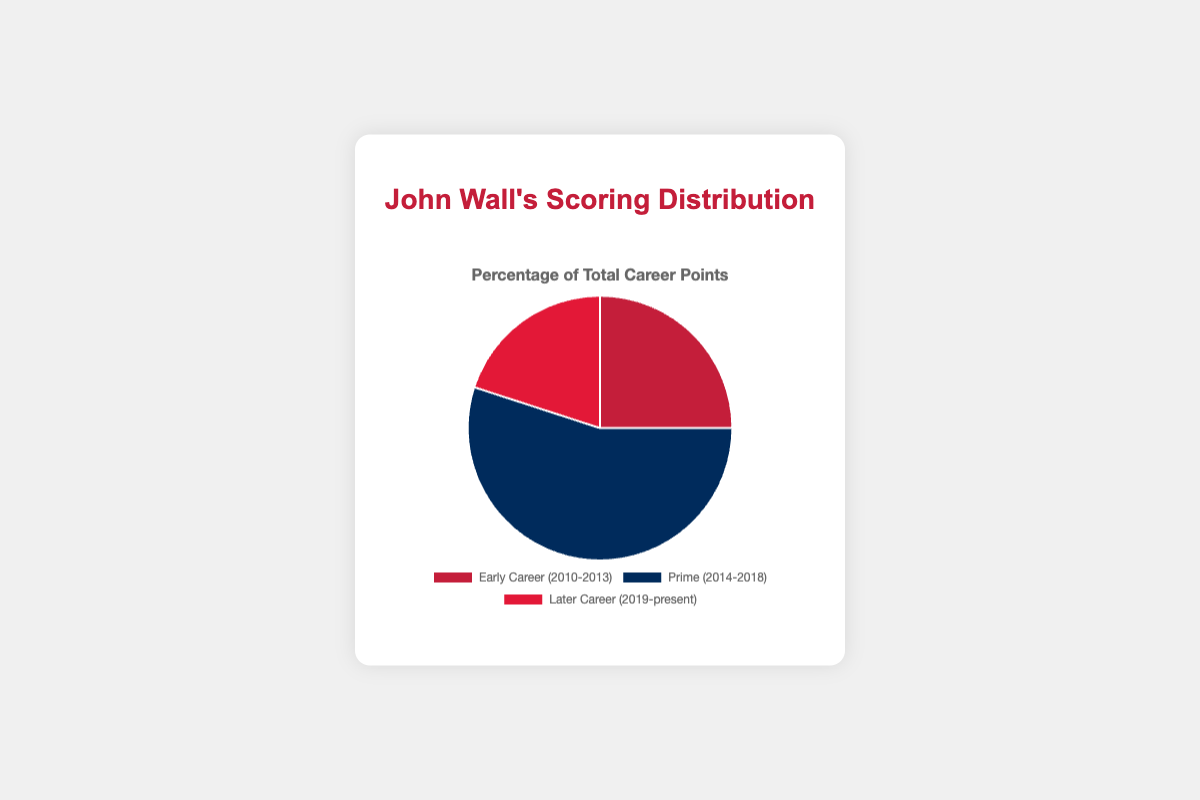What period contributed the highest percentage of John Wall's total career points? Look at the pie chart and identify the segment with the largest portion. The Prime (2014-2018) period has the largest segment, which contributes 55%.
Answer: Prime (2014-2018) How many percentage points more did John Wall score during his Prime (2014-2018) compared to his Later Career (2019-present)? Subtract the percentage of points from the Later Career (20%) from those in the Prime period (55%). 55% - 20% = 35%.
Answer: 35% What is the combined percentage of John Wall's career points scored in his Early Career (2010-2013) and Later Career (2019-present)? Add the percentages of the Early Career (25%) and Later Career (20%). 25% + 20% = 45%.
Answer: 45% What is the difference in the average points per game between John Wall's Prime (2014-2018) and Early Career (2010-2013)? Subtract the average points per game in the Early Career (16.4) from the Prime period (20.7). 20.7 - 16.4 = 4.3.
Answer: 4.3 Is the percentage of points scored in his Early Career (2010-2013) greater than or less than the percentage in his Later Career (2019-present)? Compare the two percentages: Early Career (25%) and Later Career (20%). 25% is greater than 20%.
Answer: Greater Which segment is colored blue in the pie chart? Identify the color-coded segments in the pie chart. The Prime (2014-2018) period is colored blue.
Answer: Prime (2014-2018) How much lower is the percentage of career points scored in John Wall's Later Career (2019-present) compared to his Prime (2014-2018)? Subtract the percentage in the Later Career (20%) from that of the Prime period (55%). 55% - 20% = 35%.
Answer: 35% What are the three periods listed in the pie chart? Identify the labels on the pie chart. The periods are Early Career (2010-2013), Prime (2014-2018), and Later Career (2019-present).
Answer: Early Career (2010-2013), Prime (2014-2018), Later Career (2019-present) What is the average points per game of John Wall during his Later Career (2019-present)? Refer to the pie chart and find the average points per game for the Later Career period. It is 15.2 points per game.
Answer: 15.2 